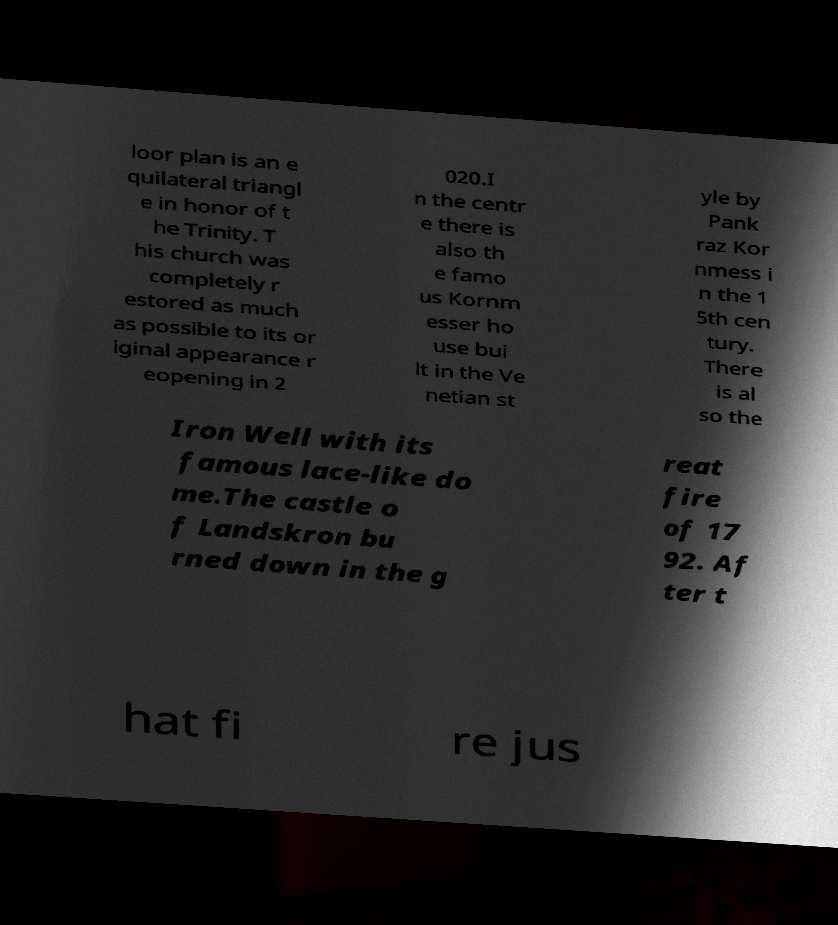Can you read and provide the text displayed in the image?This photo seems to have some interesting text. Can you extract and type it out for me? loor plan is an e quilateral triangl e in honor of t he Trinity. T his church was completely r estored as much as possible to its or iginal appearance r eopening in 2 020.I n the centr e there is also th e famo us Kornm esser ho use bui lt in the Ve netian st yle by Pank raz Kor nmess i n the 1 5th cen tury. There is al so the Iron Well with its famous lace-like do me.The castle o f Landskron bu rned down in the g reat fire of 17 92. Af ter t hat fi re jus 